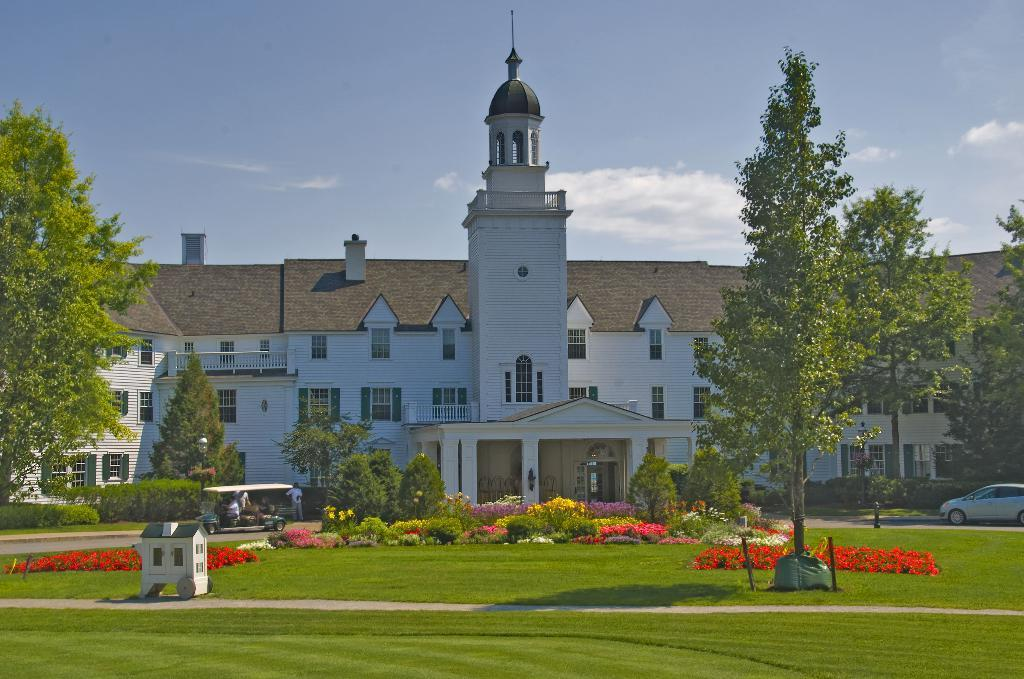What is the main structure in the image? There is a huge building in the image. What is located in front of the building? There is a garden with beautiful flowers in front of the building. What type of vegetation is present in the garden? There are trees in the garden. What is happening around the garden? Vehicles are moving around the garden. What type of insurance is being offered by the building in the image? There is no indication of insurance being offered in the image; it only shows a huge building, a garden, trees, and vehicles moving around. How many geese are present in the garden in the image? There are no geese present in the garden or the image. 